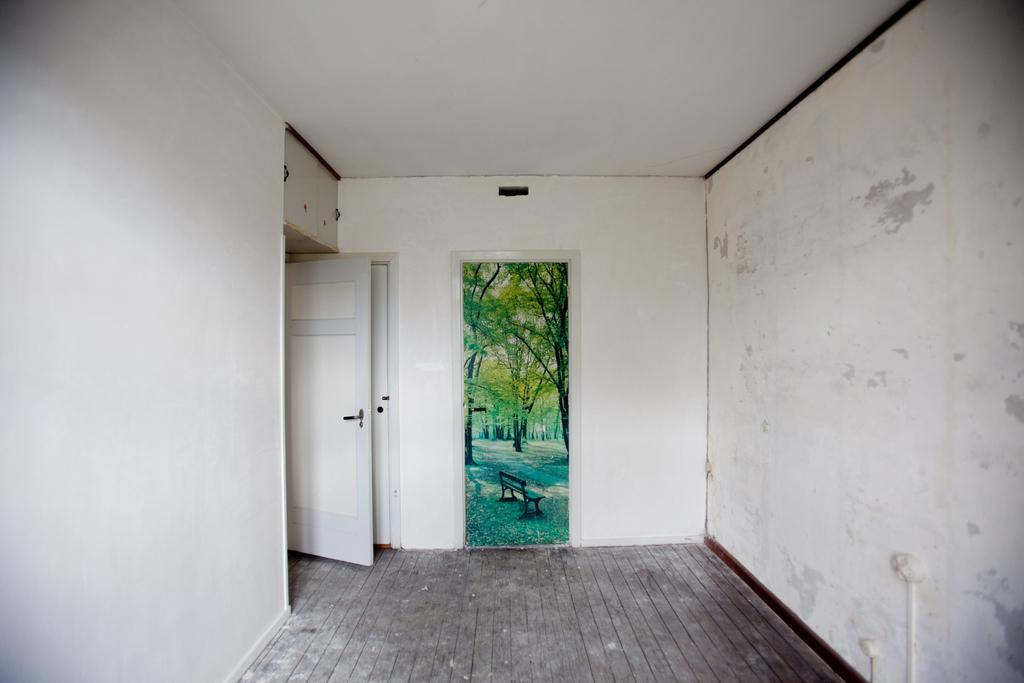What is attached to the wall in the image? There is a frame attached to the wall in the image. Where is the frame located in the image? The frame is in the middle of the image. What other architectural feature can be seen on the left side of the image? There is a door on the left side of the image. What type of curtain is hanging from the frame in the image? There is no curtain hanging from the frame in the image; it is a frame attached to the wall. Can you see a woman interacting with the door in the image? There is no woman present in the image; it only features a frame and a door. 